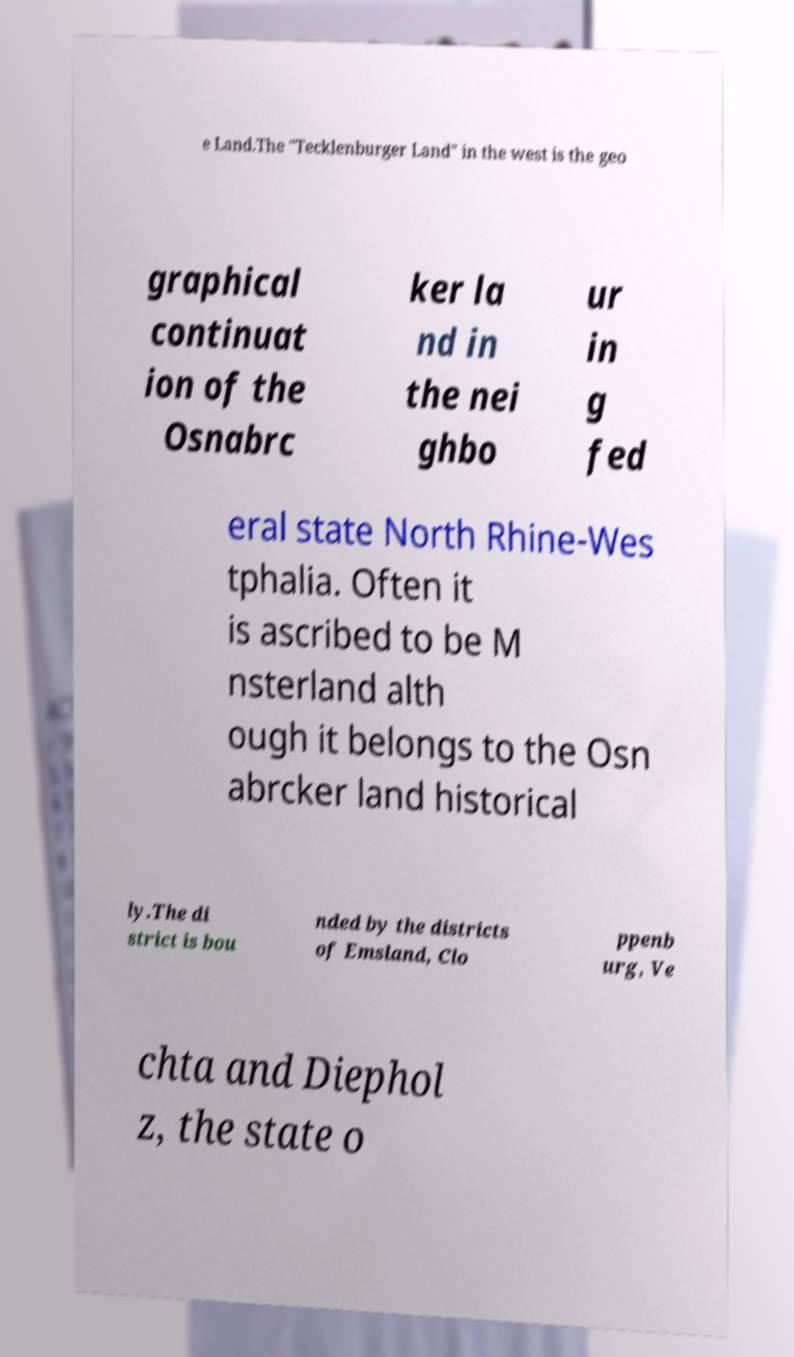What messages or text are displayed in this image? I need them in a readable, typed format. e Land.The "Tecklenburger Land" in the west is the geo graphical continuat ion of the Osnabrc ker la nd in the nei ghbo ur in g fed eral state North Rhine-Wes tphalia. Often it is ascribed to be M nsterland alth ough it belongs to the Osn abrcker land historical ly.The di strict is bou nded by the districts of Emsland, Clo ppenb urg, Ve chta and Diephol z, the state o 